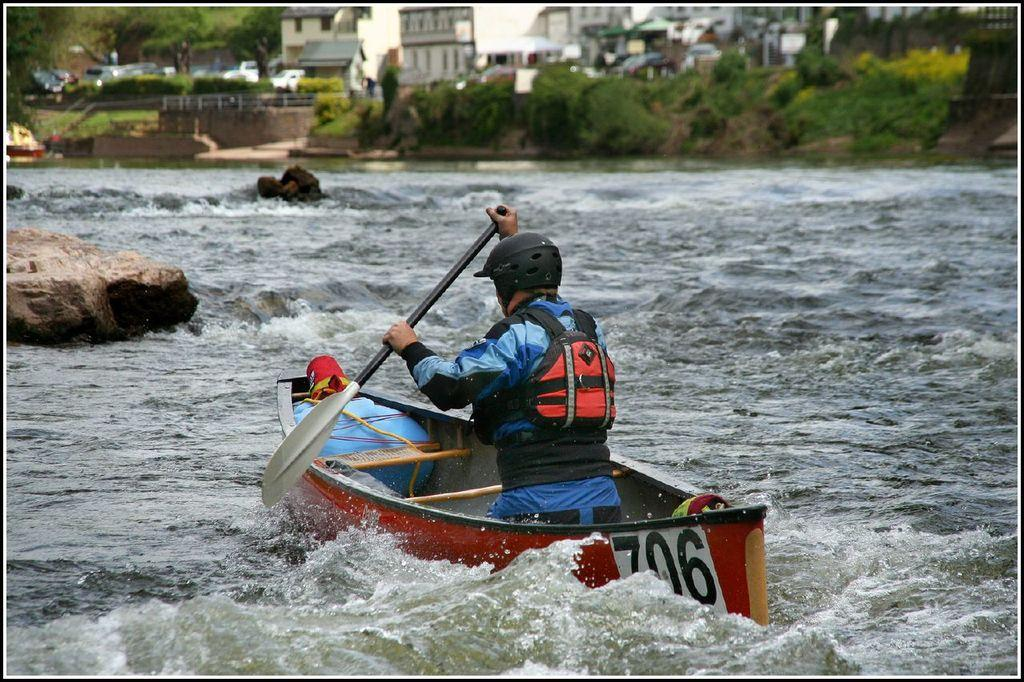Who is present in the image? There is a person in the image. What is the person doing in the image? The person is on a boat. Where is the boat located? The boat is on water. What can be seen in the background of the image? There are buildings with windows in the background of the image. How many giants are visible in the image? There are no giants present in the image. What type of muscle is being flexed by the person in the image? The image does not show the person flexing any muscles, so it cannot be determined. 